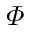Convert formula to latex. <formula><loc_0><loc_0><loc_500><loc_500>\varPhi</formula> 